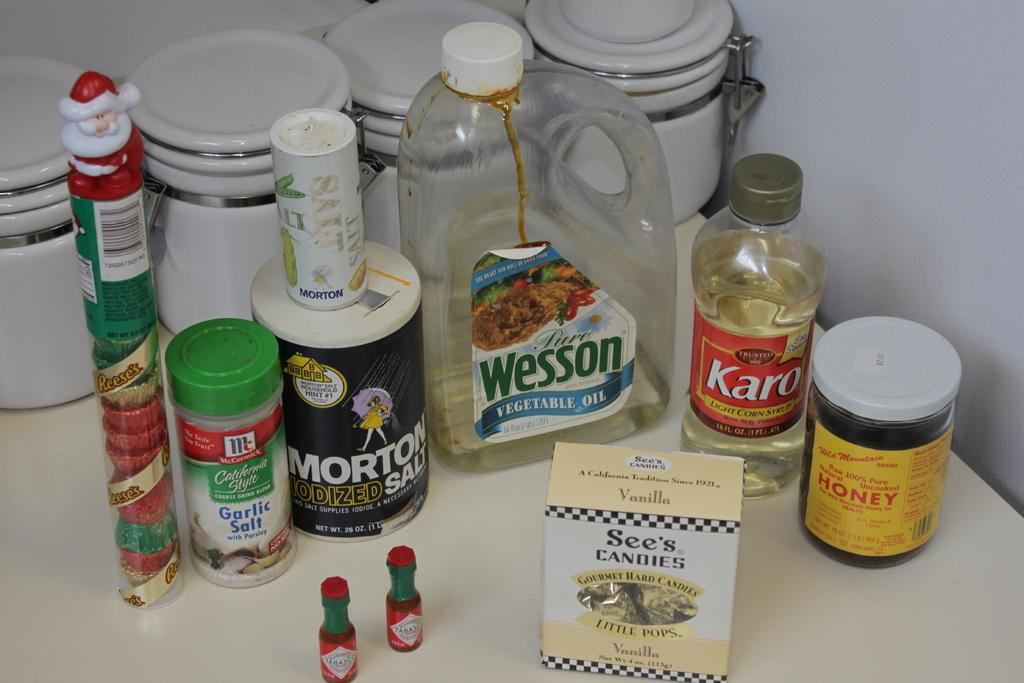<image>
Share a concise interpretation of the image provided. Several bottles and packets on a table with two small bottles of tabasco in front. 